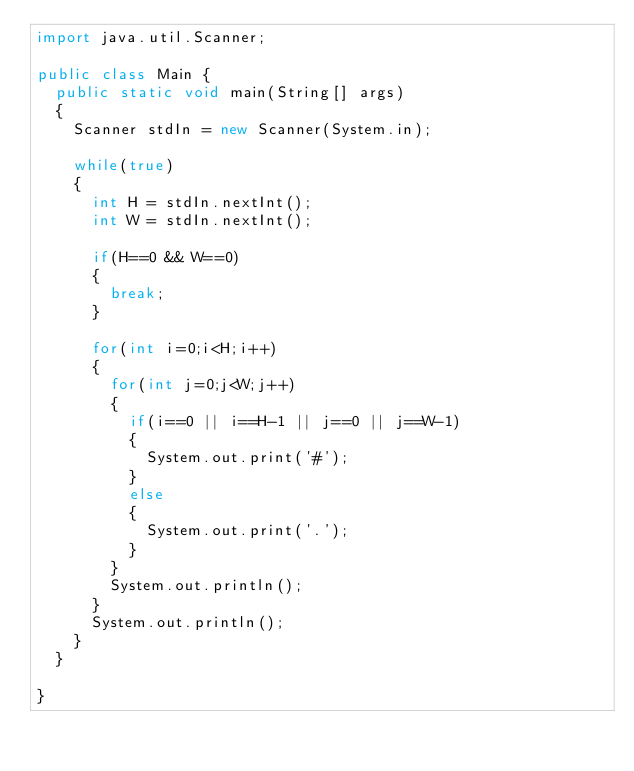Convert code to text. <code><loc_0><loc_0><loc_500><loc_500><_Java_>import java.util.Scanner;

public class Main {
	public static void main(String[] args)
	{
		Scanner stdIn = new Scanner(System.in);
		
		while(true)
		{
			int H = stdIn.nextInt();
			int W = stdIn.nextInt();
			
			if(H==0 && W==0)
			{
				break;
			}
			
			for(int i=0;i<H;i++)
			{
				for(int j=0;j<W;j++)
				{
					if(i==0 || i==H-1 || j==0 || j==W-1)
					{
						System.out.print('#');
					}
					else
					{
						System.out.print('.');
					}
				}
				System.out.println();
			}
			System.out.println();
		}
	}

}</code> 